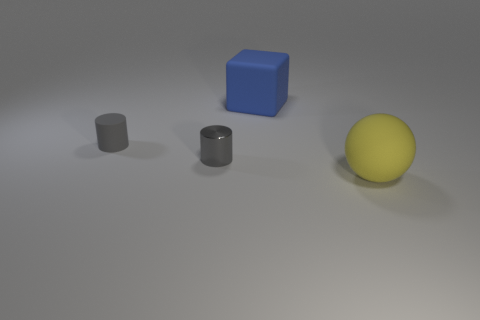There is a yellow object; how many large objects are left of it?
Your answer should be very brief. 1. Do the yellow object and the gray object that is to the right of the matte cylinder have the same material?
Your answer should be very brief. No. Is there anything else that has the same shape as the blue object?
Give a very brief answer. No. Is there a big blue object on the left side of the thing that is right of the blue rubber object?
Give a very brief answer. Yes. What number of matte things are both on the right side of the metal cylinder and behind the tiny gray metallic cylinder?
Provide a short and direct response. 1. There is a tiny gray object to the right of the gray matte cylinder; what is its shape?
Make the answer very short. Cylinder. What number of gray matte cylinders have the same size as the metallic cylinder?
Keep it short and to the point. 1. Is the color of the small rubber thing in front of the big blue matte thing the same as the metallic cylinder?
Keep it short and to the point. Yes. There is a thing that is both right of the tiny metal cylinder and behind the large yellow matte ball; what material is it?
Ensure brevity in your answer.  Rubber. Is the number of yellow matte objects greater than the number of cylinders?
Ensure brevity in your answer.  No. 